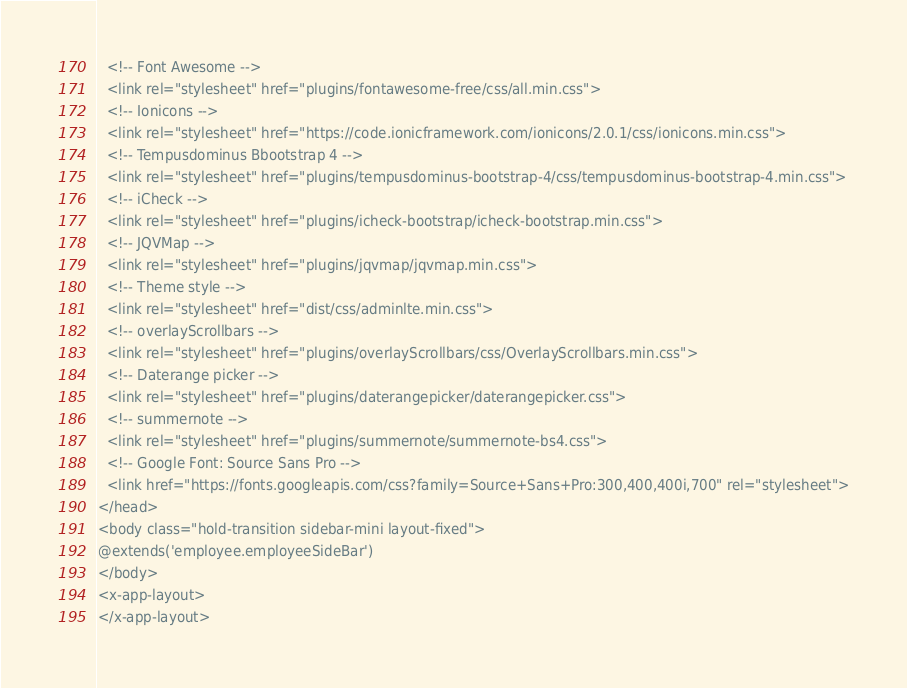Convert code to text. <code><loc_0><loc_0><loc_500><loc_500><_PHP_>  <!-- Font Awesome -->
  <link rel="stylesheet" href="plugins/fontawesome-free/css/all.min.css">
  <!-- Ionicons -->
  <link rel="stylesheet" href="https://code.ionicframework.com/ionicons/2.0.1/css/ionicons.min.css">
  <!-- Tempusdominus Bbootstrap 4 -->
  <link rel="stylesheet" href="plugins/tempusdominus-bootstrap-4/css/tempusdominus-bootstrap-4.min.css">
  <!-- iCheck -->
  <link rel="stylesheet" href="plugins/icheck-bootstrap/icheck-bootstrap.min.css">
  <!-- JQVMap -->
  <link rel="stylesheet" href="plugins/jqvmap/jqvmap.min.css">
  <!-- Theme style -->
  <link rel="stylesheet" href="dist/css/adminlte.min.css">
  <!-- overlayScrollbars -->
  <link rel="stylesheet" href="plugins/overlayScrollbars/css/OverlayScrollbars.min.css">
  <!-- Daterange picker -->
  <link rel="stylesheet" href="plugins/daterangepicker/daterangepicker.css">
  <!-- summernote -->
  <link rel="stylesheet" href="plugins/summernote/summernote-bs4.css">
  <!-- Google Font: Source Sans Pro -->
  <link href="https://fonts.googleapis.com/css?family=Source+Sans+Pro:300,400,400i,700" rel="stylesheet">
</head>
<body class="hold-transition sidebar-mini layout-fixed">
@extends('employee.employeeSideBar')
</body>
<x-app-layout>
</x-app-layout></code> 